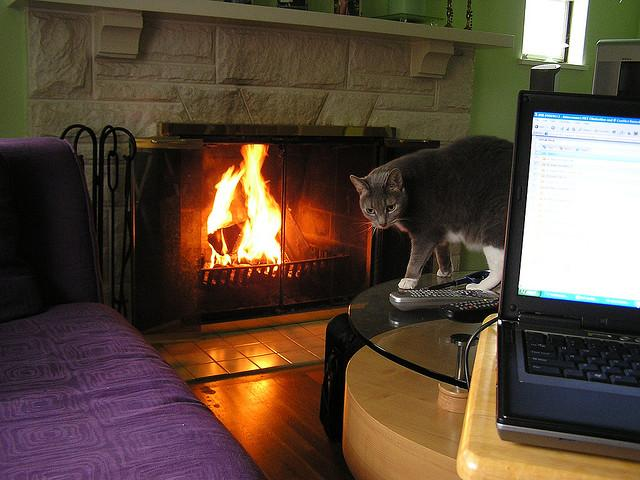What is creeping around on the table? cat 